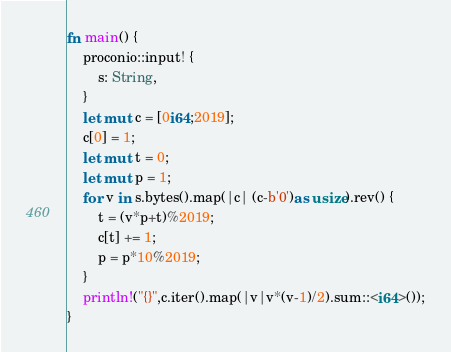<code> <loc_0><loc_0><loc_500><loc_500><_Rust_>fn main() {
    proconio::input! {
        s: String,
    }
    let mut c = [0i64;2019];
    c[0] = 1;
    let mut t = 0;
    let mut p = 1;
    for v in s.bytes().map(|c| (c-b'0')as usize).rev() {
        t = (v*p+t)%2019;
        c[t] += 1;
        p = p*10%2019;
    }
    println!("{}",c.iter().map(|v|v*(v-1)/2).sum::<i64>());
}</code> 